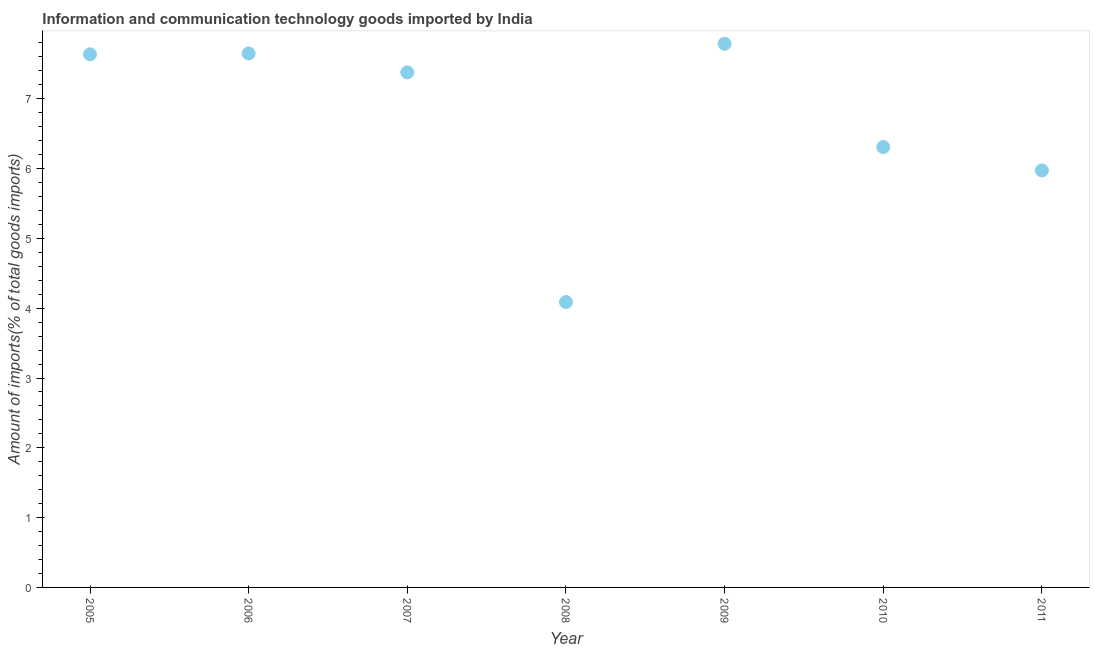What is the amount of ict goods imports in 2009?
Keep it short and to the point. 7.79. Across all years, what is the maximum amount of ict goods imports?
Your response must be concise. 7.79. Across all years, what is the minimum amount of ict goods imports?
Your response must be concise. 4.09. What is the sum of the amount of ict goods imports?
Make the answer very short. 46.82. What is the difference between the amount of ict goods imports in 2010 and 2011?
Your answer should be compact. 0.33. What is the average amount of ict goods imports per year?
Give a very brief answer. 6.69. What is the median amount of ict goods imports?
Keep it short and to the point. 7.38. What is the ratio of the amount of ict goods imports in 2006 to that in 2007?
Provide a succinct answer. 1.04. Is the difference between the amount of ict goods imports in 2005 and 2007 greater than the difference between any two years?
Keep it short and to the point. No. What is the difference between the highest and the second highest amount of ict goods imports?
Ensure brevity in your answer.  0.14. What is the difference between the highest and the lowest amount of ict goods imports?
Offer a terse response. 3.7. In how many years, is the amount of ict goods imports greater than the average amount of ict goods imports taken over all years?
Provide a short and direct response. 4. Does the amount of ict goods imports monotonically increase over the years?
Your answer should be very brief. No. Does the graph contain any zero values?
Offer a terse response. No. What is the title of the graph?
Your answer should be compact. Information and communication technology goods imported by India. What is the label or title of the X-axis?
Provide a short and direct response. Year. What is the label or title of the Y-axis?
Your answer should be very brief. Amount of imports(% of total goods imports). What is the Amount of imports(% of total goods imports) in 2005?
Make the answer very short. 7.64. What is the Amount of imports(% of total goods imports) in 2006?
Ensure brevity in your answer.  7.65. What is the Amount of imports(% of total goods imports) in 2007?
Offer a very short reply. 7.38. What is the Amount of imports(% of total goods imports) in 2008?
Offer a terse response. 4.09. What is the Amount of imports(% of total goods imports) in 2009?
Make the answer very short. 7.79. What is the Amount of imports(% of total goods imports) in 2010?
Give a very brief answer. 6.31. What is the Amount of imports(% of total goods imports) in 2011?
Provide a succinct answer. 5.97. What is the difference between the Amount of imports(% of total goods imports) in 2005 and 2006?
Offer a terse response. -0.01. What is the difference between the Amount of imports(% of total goods imports) in 2005 and 2007?
Keep it short and to the point. 0.26. What is the difference between the Amount of imports(% of total goods imports) in 2005 and 2008?
Give a very brief answer. 3.55. What is the difference between the Amount of imports(% of total goods imports) in 2005 and 2009?
Offer a very short reply. -0.15. What is the difference between the Amount of imports(% of total goods imports) in 2005 and 2010?
Give a very brief answer. 1.33. What is the difference between the Amount of imports(% of total goods imports) in 2005 and 2011?
Make the answer very short. 1.66. What is the difference between the Amount of imports(% of total goods imports) in 2006 and 2007?
Provide a short and direct response. 0.27. What is the difference between the Amount of imports(% of total goods imports) in 2006 and 2008?
Give a very brief answer. 3.56. What is the difference between the Amount of imports(% of total goods imports) in 2006 and 2009?
Keep it short and to the point. -0.14. What is the difference between the Amount of imports(% of total goods imports) in 2006 and 2010?
Your answer should be compact. 1.34. What is the difference between the Amount of imports(% of total goods imports) in 2006 and 2011?
Keep it short and to the point. 1.68. What is the difference between the Amount of imports(% of total goods imports) in 2007 and 2008?
Ensure brevity in your answer.  3.29. What is the difference between the Amount of imports(% of total goods imports) in 2007 and 2009?
Ensure brevity in your answer.  -0.41. What is the difference between the Amount of imports(% of total goods imports) in 2007 and 2010?
Ensure brevity in your answer.  1.07. What is the difference between the Amount of imports(% of total goods imports) in 2007 and 2011?
Your answer should be compact. 1.41. What is the difference between the Amount of imports(% of total goods imports) in 2008 and 2009?
Make the answer very short. -3.7. What is the difference between the Amount of imports(% of total goods imports) in 2008 and 2010?
Give a very brief answer. -2.22. What is the difference between the Amount of imports(% of total goods imports) in 2008 and 2011?
Provide a short and direct response. -1.89. What is the difference between the Amount of imports(% of total goods imports) in 2009 and 2010?
Provide a succinct answer. 1.48. What is the difference between the Amount of imports(% of total goods imports) in 2009 and 2011?
Provide a short and direct response. 1.82. What is the difference between the Amount of imports(% of total goods imports) in 2010 and 2011?
Make the answer very short. 0.33. What is the ratio of the Amount of imports(% of total goods imports) in 2005 to that in 2007?
Offer a very short reply. 1.03. What is the ratio of the Amount of imports(% of total goods imports) in 2005 to that in 2008?
Keep it short and to the point. 1.87. What is the ratio of the Amount of imports(% of total goods imports) in 2005 to that in 2010?
Your answer should be compact. 1.21. What is the ratio of the Amount of imports(% of total goods imports) in 2005 to that in 2011?
Make the answer very short. 1.28. What is the ratio of the Amount of imports(% of total goods imports) in 2006 to that in 2007?
Offer a very short reply. 1.04. What is the ratio of the Amount of imports(% of total goods imports) in 2006 to that in 2008?
Provide a short and direct response. 1.87. What is the ratio of the Amount of imports(% of total goods imports) in 2006 to that in 2010?
Make the answer very short. 1.21. What is the ratio of the Amount of imports(% of total goods imports) in 2006 to that in 2011?
Give a very brief answer. 1.28. What is the ratio of the Amount of imports(% of total goods imports) in 2007 to that in 2008?
Make the answer very short. 1.8. What is the ratio of the Amount of imports(% of total goods imports) in 2007 to that in 2009?
Offer a very short reply. 0.95. What is the ratio of the Amount of imports(% of total goods imports) in 2007 to that in 2010?
Give a very brief answer. 1.17. What is the ratio of the Amount of imports(% of total goods imports) in 2007 to that in 2011?
Provide a short and direct response. 1.24. What is the ratio of the Amount of imports(% of total goods imports) in 2008 to that in 2009?
Your answer should be very brief. 0.53. What is the ratio of the Amount of imports(% of total goods imports) in 2008 to that in 2010?
Offer a terse response. 0.65. What is the ratio of the Amount of imports(% of total goods imports) in 2008 to that in 2011?
Ensure brevity in your answer.  0.68. What is the ratio of the Amount of imports(% of total goods imports) in 2009 to that in 2010?
Make the answer very short. 1.24. What is the ratio of the Amount of imports(% of total goods imports) in 2009 to that in 2011?
Provide a short and direct response. 1.3. What is the ratio of the Amount of imports(% of total goods imports) in 2010 to that in 2011?
Provide a short and direct response. 1.06. 